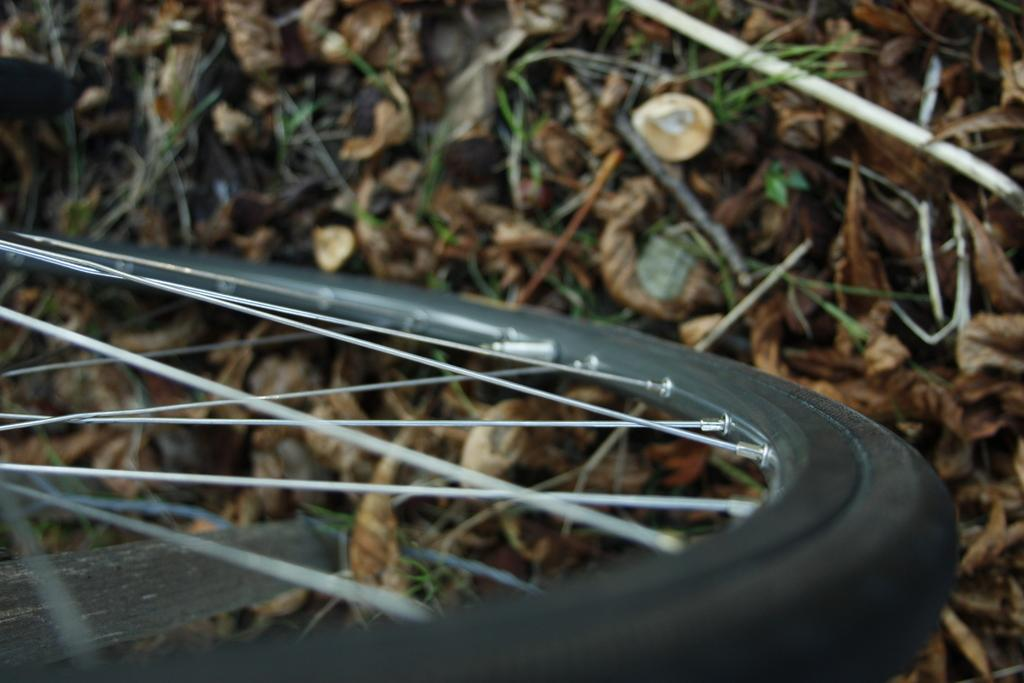What object is located at the front of the image? There is a tyre in the front of the image. What can be seen in the background of the image? There are dry leaves in the background of the image. What type of voice can be heard coming from the throne in the image? There is no throne present in the image, so it is not possible to determine what type of voice might be heard. 